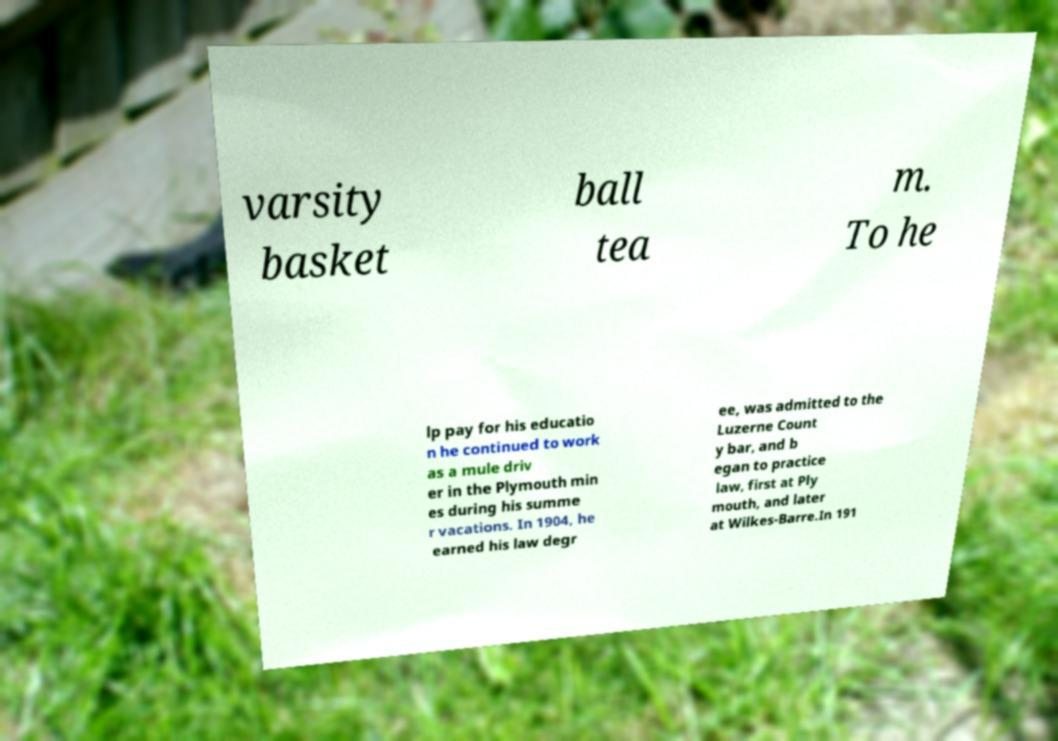Please identify and transcribe the text found in this image. varsity basket ball tea m. To he lp pay for his educatio n he continued to work as a mule driv er in the Plymouth min es during his summe r vacations. In 1904, he earned his law degr ee, was admitted to the Luzerne Count y bar, and b egan to practice law, first at Ply mouth, and later at Wilkes-Barre.In 191 